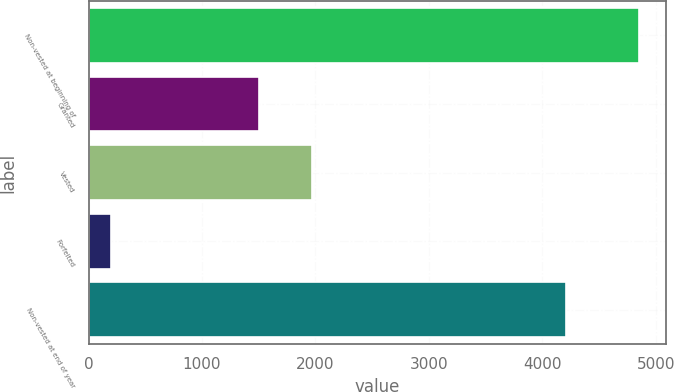Convert chart to OTSL. <chart><loc_0><loc_0><loc_500><loc_500><bar_chart><fcel>Non-vested at beginning of<fcel>Granted<fcel>Vested<fcel>Forfeited<fcel>Non-vested at end of year<nl><fcel>4849<fcel>1500<fcel>1965.1<fcel>198<fcel>4208<nl></chart> 